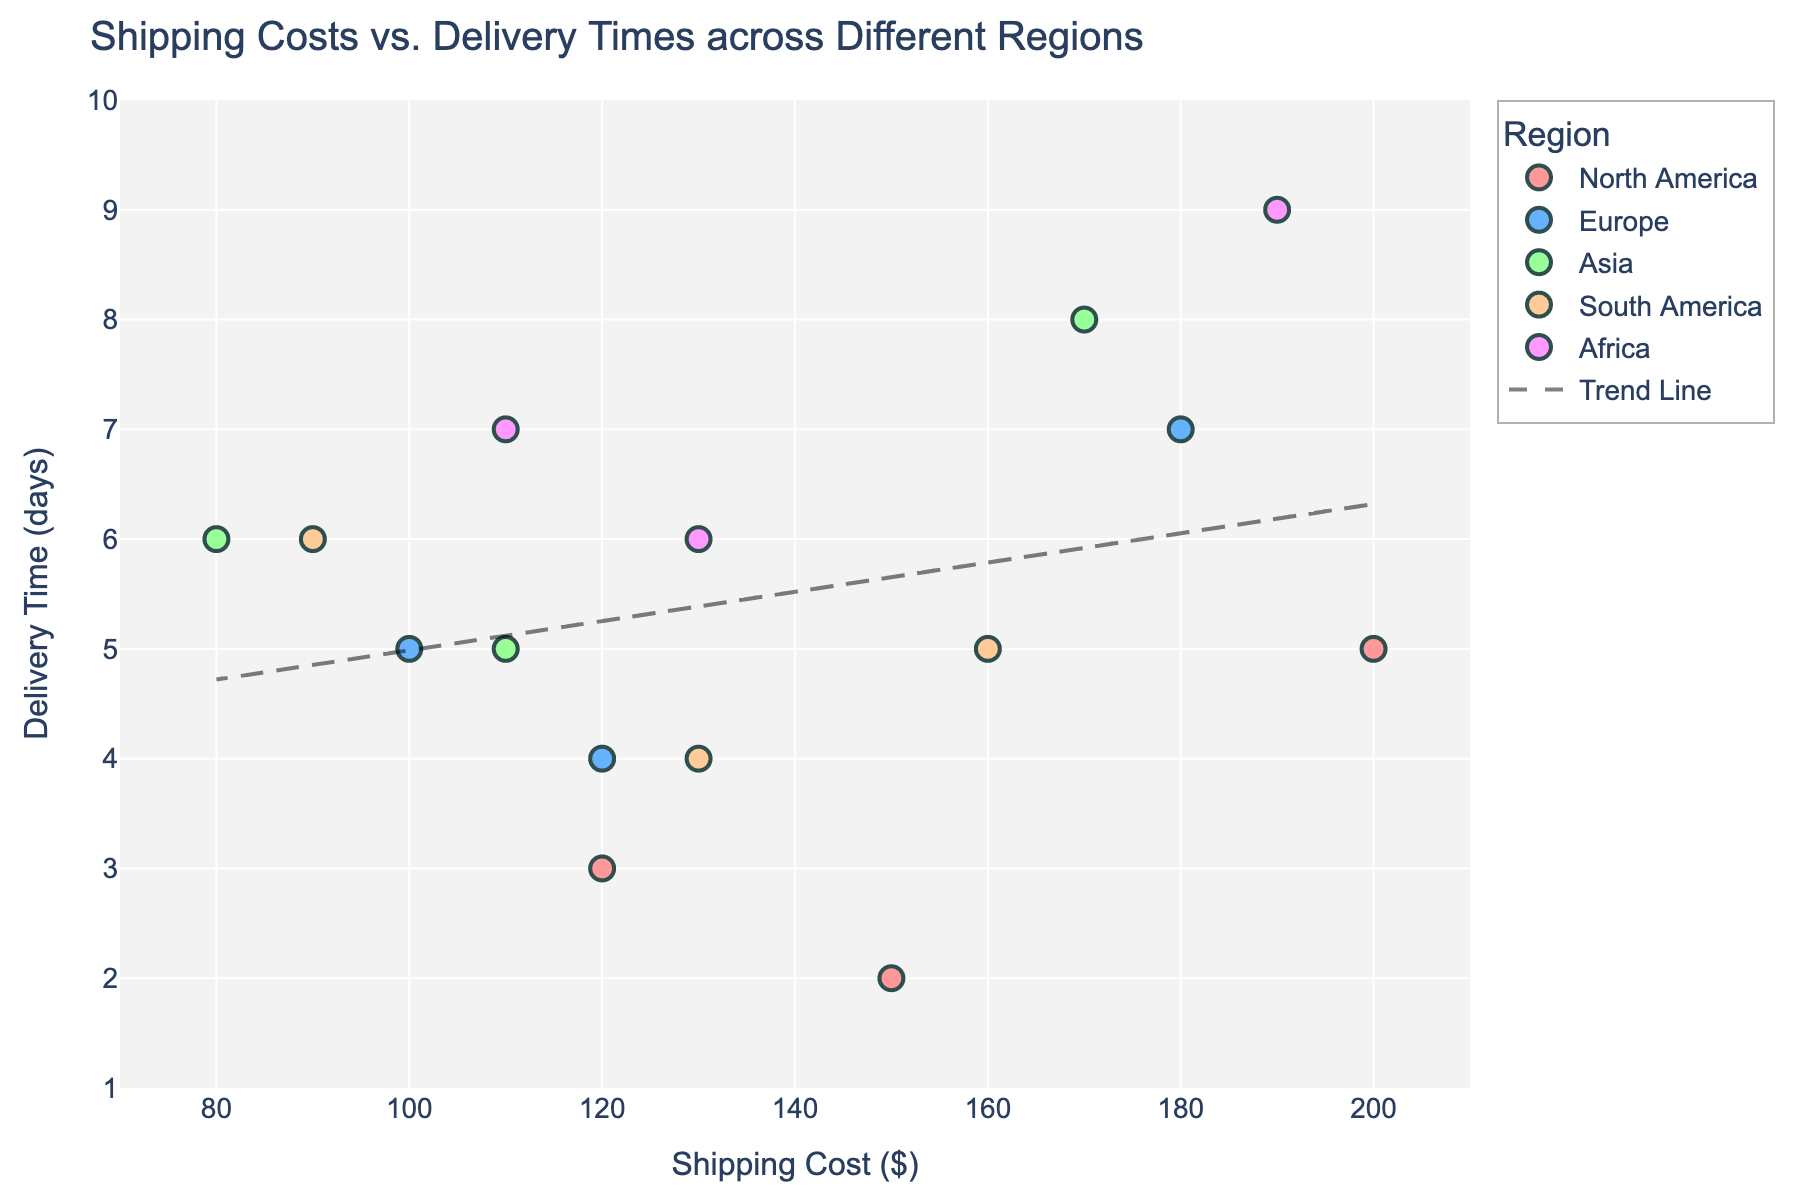What is the title of the plot? The title of the plot is usually displayed at the top center of the figure, summarizing the visualized data. In this case, it clearly states "Shipping Costs vs. Delivery Times across Different Regions".
Answer: Shipping Costs vs. Delivery Times across Different Regions How many regions are represented in the plot? By looking at the legend, we can see different colors that represent different regions. These regions are North America, Europe, Asia, South America, and Africa.
Answer: 5 Which region appears to have the lowest shipping cost? By examining the scatter plot and observing the x-axis (Shipping Cost), the region with the leftmost data points (lowest shipping cost) is Asia with a shipping cost as low as $80.
Answer: Asia What is the highest recorded delivery time, and which region does it belong to? To identify the highest recorded delivery time, we look at the uppermost data point on the y-axis (Delivery Time). The point at Delivery Time of 9 days belongs to Africa.
Answer: 9 days, Africa On average, which region has the earliest delivery times? To determine the region with the earliest delivery times, observe the approximate central values of the delivery times for each region. North America appears to have lower delivery times compared to other regions, averaging around 3 days.
Answer: North America Which data points are closest to the trend line? To find the data points closest to the trend line, compare the distances of points from the line visually. Points in South America often lie near the trend line.
Answer: South America Which regions have data points that both fall below and above the trend line? By checking the data points' positions relative to the trend line, we see that Europe, Asia, and Africa have points on both sides of the trend line.
Answer: Europe, Asia, Africa What can be inferred about the relationship between shipping costs and delivery times from the trend line? The trend line indicates a positive correlation, meaning that as shipping costs increase, delivery times tend to also increase. The inclination of the trend line suggests that typically higher shipping costs result in longer delivery times.
Answer: Positive correlation What is the range of shipping costs for North America? The shipping costs for North America, marked by its points on the x-axis, range from $120 to $200.
Answer: $120 - $200 Are the delivery times for Africa more variable than those of Europe? Comparing the spread of data points along the y-axis (Delivery Time) for Africa and Europe, we see that Africa's delivery times range from 6 to 9 days, showing more variability than Europe's 4 to 7 days.
Answer: Yes 